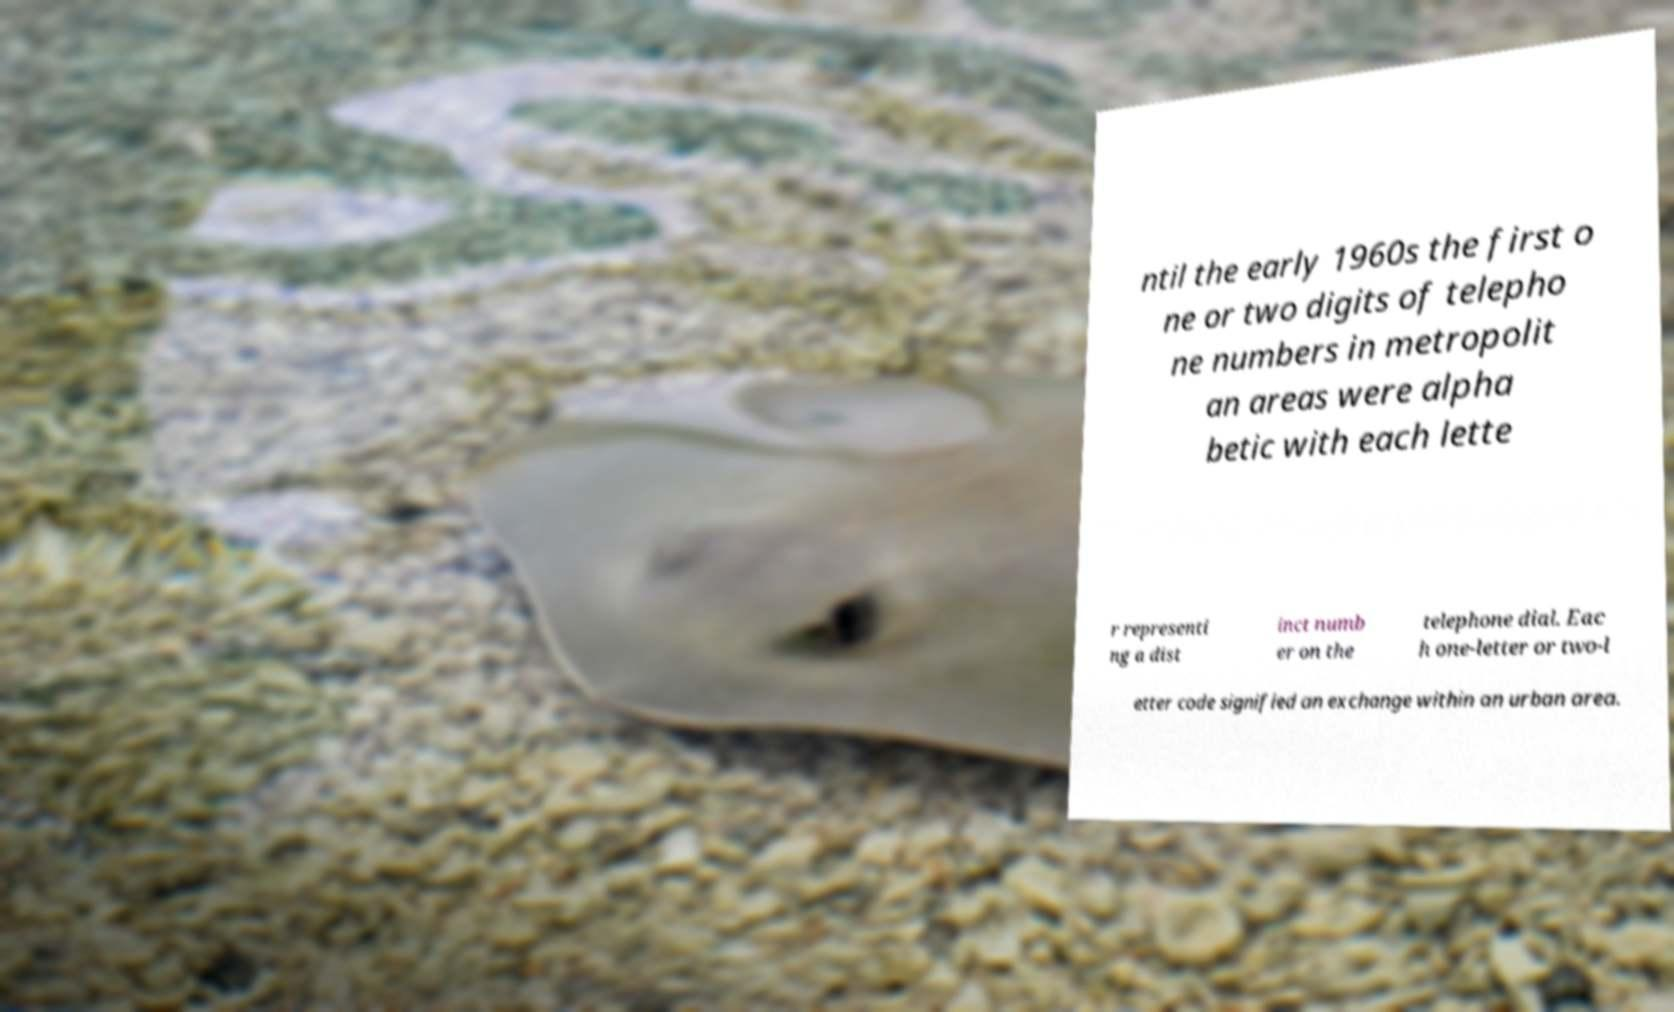For documentation purposes, I need the text within this image transcribed. Could you provide that? ntil the early 1960s the first o ne or two digits of telepho ne numbers in metropolit an areas were alpha betic with each lette r representi ng a dist inct numb er on the telephone dial. Eac h one-letter or two-l etter code signified an exchange within an urban area. 